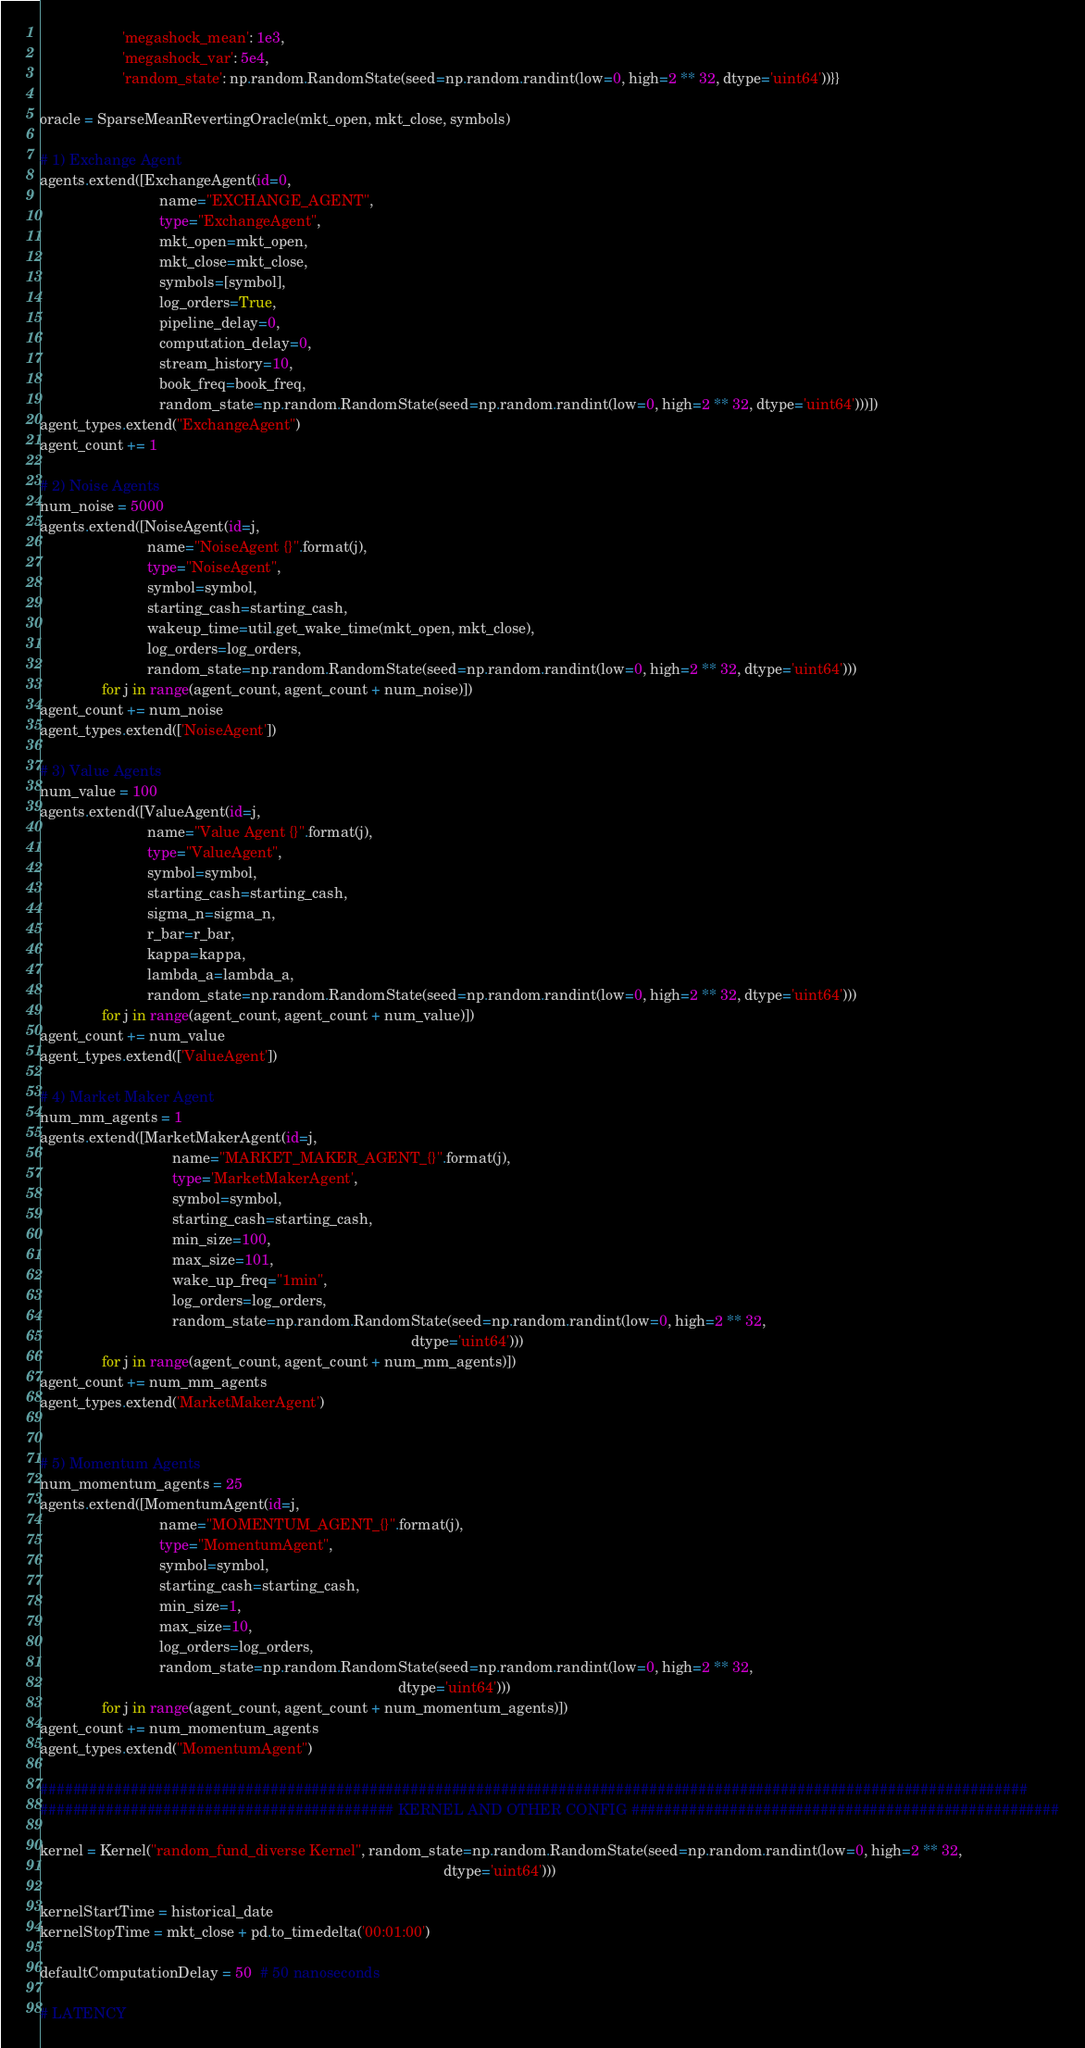Convert code to text. <code><loc_0><loc_0><loc_500><loc_500><_Python_>                    'megashock_mean': 1e3,
                    'megashock_var': 5e4,
                    'random_state': np.random.RandomState(seed=np.random.randint(low=0, high=2 ** 32, dtype='uint64'))}}

oracle = SparseMeanRevertingOracle(mkt_open, mkt_close, symbols)

# 1) Exchange Agent
agents.extend([ExchangeAgent(id=0,
                             name="EXCHANGE_AGENT",
                             type="ExchangeAgent",
                             mkt_open=mkt_open,
                             mkt_close=mkt_close,
                             symbols=[symbol],
                             log_orders=True,
                             pipeline_delay=0,
                             computation_delay=0,
                             stream_history=10,
                             book_freq=book_freq,
                             random_state=np.random.RandomState(seed=np.random.randint(low=0, high=2 ** 32, dtype='uint64')))])
agent_types.extend("ExchangeAgent")
agent_count += 1

# 2) Noise Agents
num_noise = 5000
agents.extend([NoiseAgent(id=j,
                          name="NoiseAgent {}".format(j),
                          type="NoiseAgent",
                          symbol=symbol,
                          starting_cash=starting_cash,
                          wakeup_time=util.get_wake_time(mkt_open, mkt_close),
                          log_orders=log_orders,
                          random_state=np.random.RandomState(seed=np.random.randint(low=0, high=2 ** 32, dtype='uint64')))
               for j in range(agent_count, agent_count + num_noise)])
agent_count += num_noise
agent_types.extend(['NoiseAgent'])

# 3) Value Agents
num_value = 100
agents.extend([ValueAgent(id=j,
                          name="Value Agent {}".format(j),
                          type="ValueAgent",
                          symbol=symbol,
                          starting_cash=starting_cash,
                          sigma_n=sigma_n,
                          r_bar=r_bar,
                          kappa=kappa,
                          lambda_a=lambda_a,
                          random_state=np.random.RandomState(seed=np.random.randint(low=0, high=2 ** 32, dtype='uint64')))
               for j in range(agent_count, agent_count + num_value)])
agent_count += num_value
agent_types.extend(['ValueAgent'])

# 4) Market Maker Agent
num_mm_agents = 1
agents.extend([MarketMakerAgent(id=j,
                                name="MARKET_MAKER_AGENT_{}".format(j),
                                type='MarketMakerAgent',
                                symbol=symbol,
                                starting_cash=starting_cash,
                                min_size=100,
                                max_size=101,
                                wake_up_freq="1min",
                                log_orders=log_orders,
                                random_state=np.random.RandomState(seed=np.random.randint(low=0, high=2 ** 32,
                                                                                          dtype='uint64')))
               for j in range(agent_count, agent_count + num_mm_agents)])
agent_count += num_mm_agents
agent_types.extend('MarketMakerAgent')


# 5) Momentum Agents
num_momentum_agents = 25
agents.extend([MomentumAgent(id=j,
                             name="MOMENTUM_AGENT_{}".format(j),
                             type="MomentumAgent",
                             symbol=symbol,
                             starting_cash=starting_cash,
                             min_size=1,
                             max_size=10,
                             log_orders=log_orders,
                             random_state=np.random.RandomState(seed=np.random.randint(low=0, high=2 ** 32,
                                                                                       dtype='uint64')))
               for j in range(agent_count, agent_count + num_momentum_agents)])
agent_count += num_momentum_agents
agent_types.extend("MomentumAgent")

########################################################################################################################
########################################### KERNEL AND OTHER CONFIG ####################################################

kernel = Kernel("random_fund_diverse Kernel", random_state=np.random.RandomState(seed=np.random.randint(low=0, high=2 ** 32,
                                                                                                  dtype='uint64')))

kernelStartTime = historical_date
kernelStopTime = mkt_close + pd.to_timedelta('00:01:00')

defaultComputationDelay = 50  # 50 nanoseconds

# LATENCY
</code> 